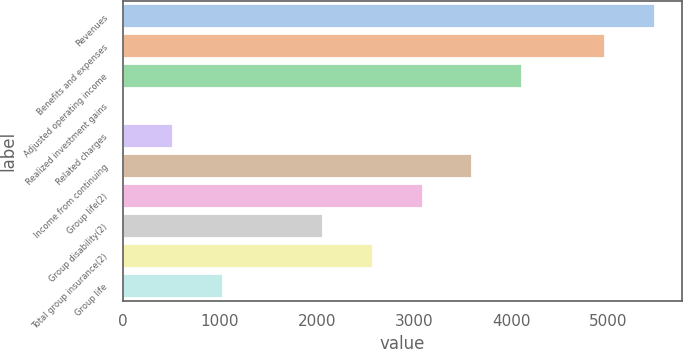Convert chart to OTSL. <chart><loc_0><loc_0><loc_500><loc_500><bar_chart><fcel>Revenues<fcel>Benefits and expenses<fcel>Adjusted operating income<fcel>Realized investment gains<fcel>Related charges<fcel>Income from continuing<fcel>Group life(2)<fcel>Group disability(2)<fcel>Total group insurance(2)<fcel>Group life<nl><fcel>5481.2<fcel>4967<fcel>4114.6<fcel>1<fcel>515.2<fcel>3600.4<fcel>3086.2<fcel>2057.8<fcel>2572<fcel>1029.4<nl></chart> 